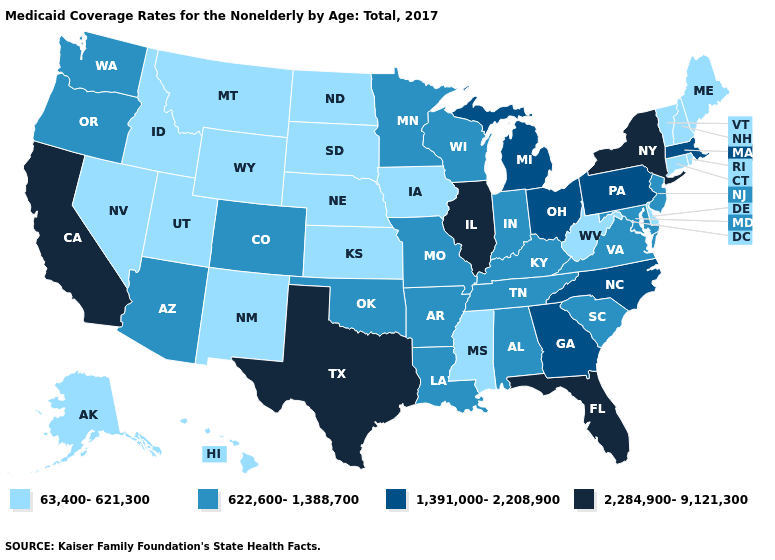Does the first symbol in the legend represent the smallest category?
Be succinct. Yes. Name the states that have a value in the range 622,600-1,388,700?
Answer briefly. Alabama, Arizona, Arkansas, Colorado, Indiana, Kentucky, Louisiana, Maryland, Minnesota, Missouri, New Jersey, Oklahoma, Oregon, South Carolina, Tennessee, Virginia, Washington, Wisconsin. What is the value of Texas?
Quick response, please. 2,284,900-9,121,300. What is the highest value in the West ?
Short answer required. 2,284,900-9,121,300. What is the value of Florida?
Write a very short answer. 2,284,900-9,121,300. Name the states that have a value in the range 2,284,900-9,121,300?
Concise answer only. California, Florida, Illinois, New York, Texas. Among the states that border Idaho , which have the lowest value?
Quick response, please. Montana, Nevada, Utah, Wyoming. Does West Virginia have the same value as Michigan?
Concise answer only. No. Name the states that have a value in the range 2,284,900-9,121,300?
Keep it brief. California, Florida, Illinois, New York, Texas. What is the highest value in the USA?
Write a very short answer. 2,284,900-9,121,300. How many symbols are there in the legend?
Quick response, please. 4. What is the value of Indiana?
Write a very short answer. 622,600-1,388,700. Is the legend a continuous bar?
Write a very short answer. No. Name the states that have a value in the range 622,600-1,388,700?
Concise answer only. Alabama, Arizona, Arkansas, Colorado, Indiana, Kentucky, Louisiana, Maryland, Minnesota, Missouri, New Jersey, Oklahoma, Oregon, South Carolina, Tennessee, Virginia, Washington, Wisconsin. What is the value of Missouri?
Write a very short answer. 622,600-1,388,700. 